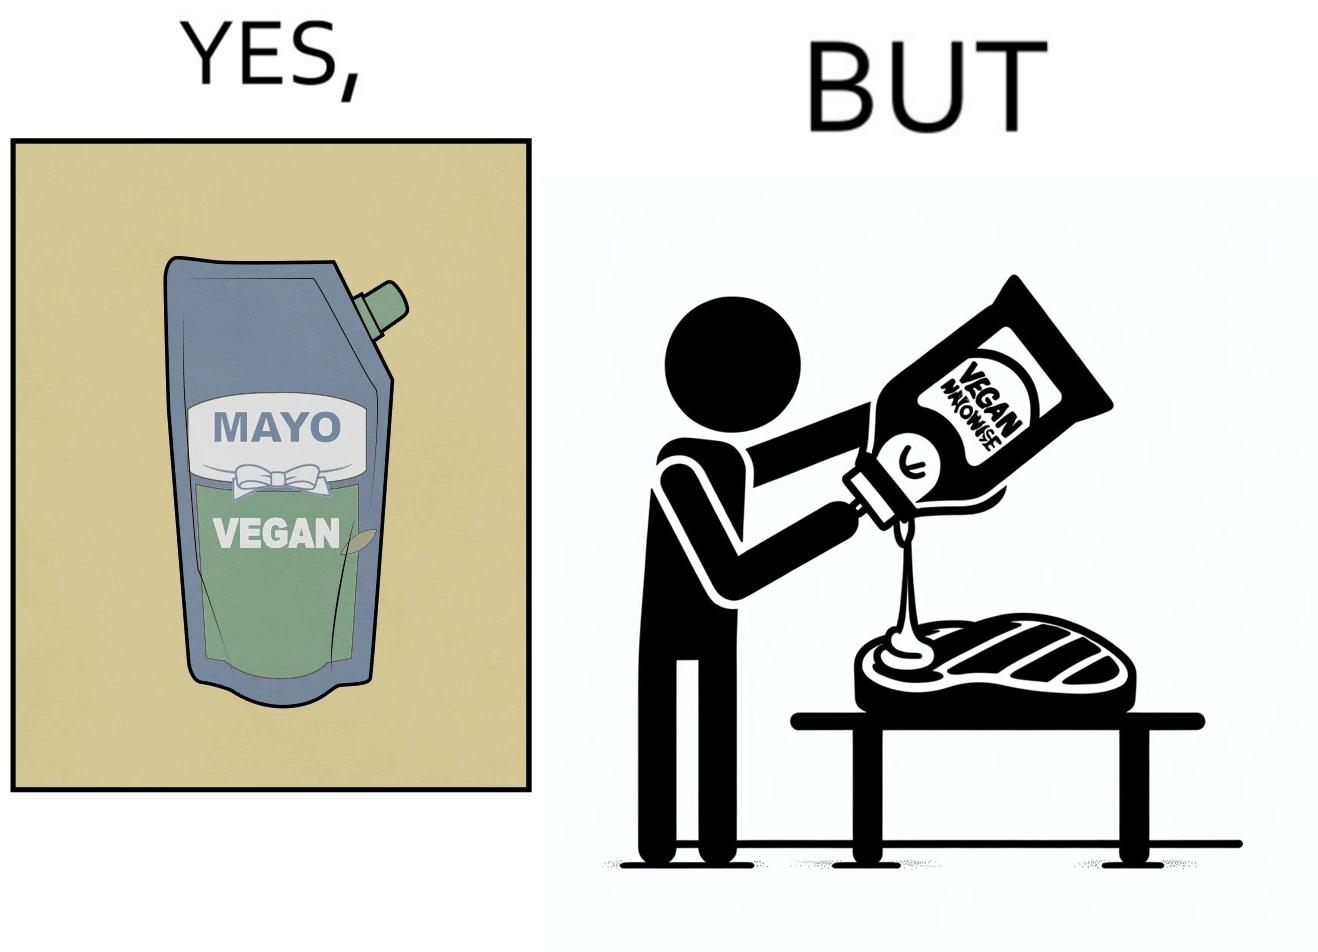Explain why this image is satirical. The image is ironical, as vegan mayo sauce is being poured on rib steak, which is non-vegetarian. The person might as well just use normal mayo sauce instead. 